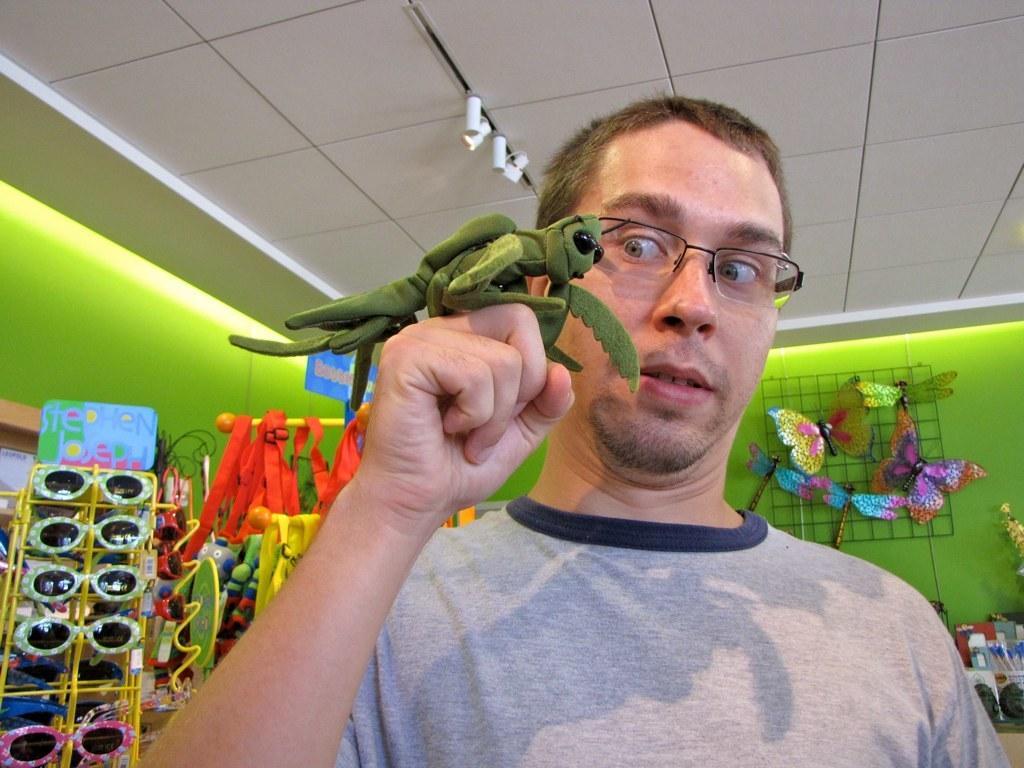Could you give a brief overview of what you see in this image? In this picture we can see a man carrying an animal toy on his fist and looking at it. In the background we have many toys like goggles, butterflies etc., 